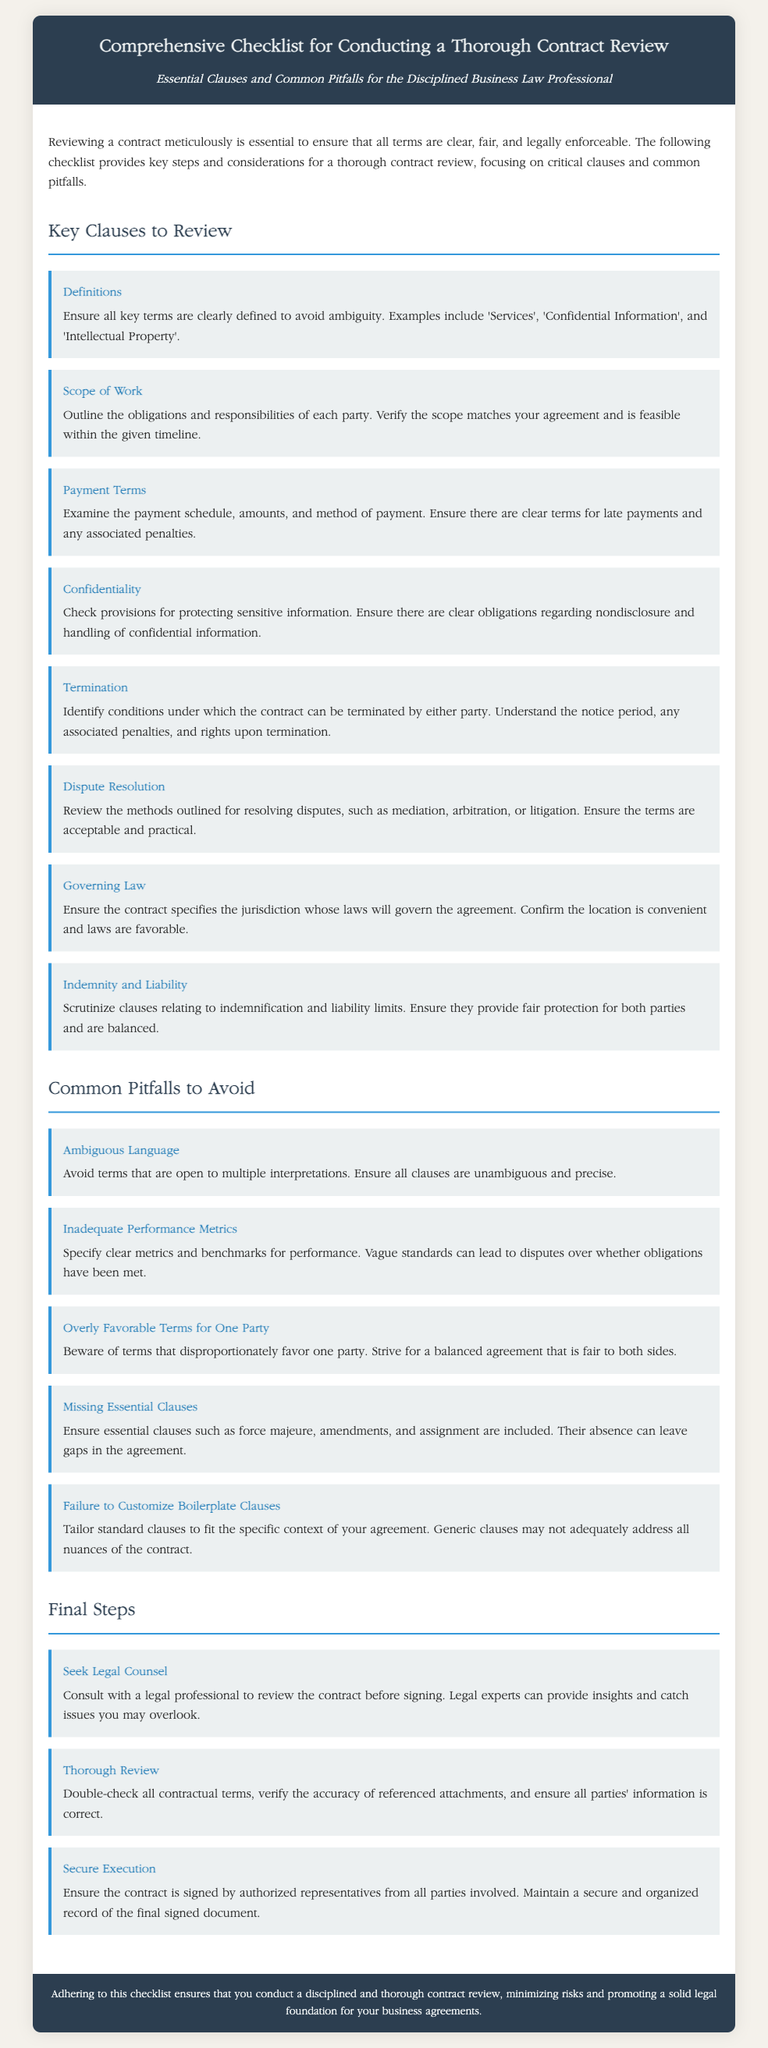What is the title of the document? The title of the document is specified in the header section, which reads "Comprehensive Checklist for Conducting a Thorough Contract Review."
Answer: Comprehensive Checklist for Conducting a Thorough Contract Review What is the subtitle of the document? The subtitle is mentioned directly under the title in the header, indicating the purpose of the checklist.
Answer: Essential Clauses and Common Pitfalls for the Disciplined Business Law Professional How many key clauses are identified in the document? The document lists specific key clauses that should be reviewed, which are enumerated in the section heading.
Answer: Eight What clause should ensure protection for sensitive information? This clause is explicitly mentioned in the section detailing key clauses and relates to confidential information handling.
Answer: Confidentiality What is one common pitfall to avoid during contract review? The document highlights potential pitfalls to consider, specifically regarding how they affect the agreement's clarity.
Answer: Ambiguous Language What final step suggests seeking help from a legal professional? This advice is part of the final steps outlined to ensure thorough contract review and is essential for legal validation.
Answer: Seek Legal Counsel What is meant by “scope of work” in the context of contract review? This term is explained in the checklist under key clauses, detailing what it encompasses in terms of obligations.
Answer: Obligations and responsibilities What should be verified related to payment terms? The checklist under key clauses specifies what elements of the payment schedule need particular attention.
Answer: Payment schedule, amounts, and method of payment What color is the header background? This detail is visually observable in the rendered document's CSS styling for the header section.
Answer: Dark blue 